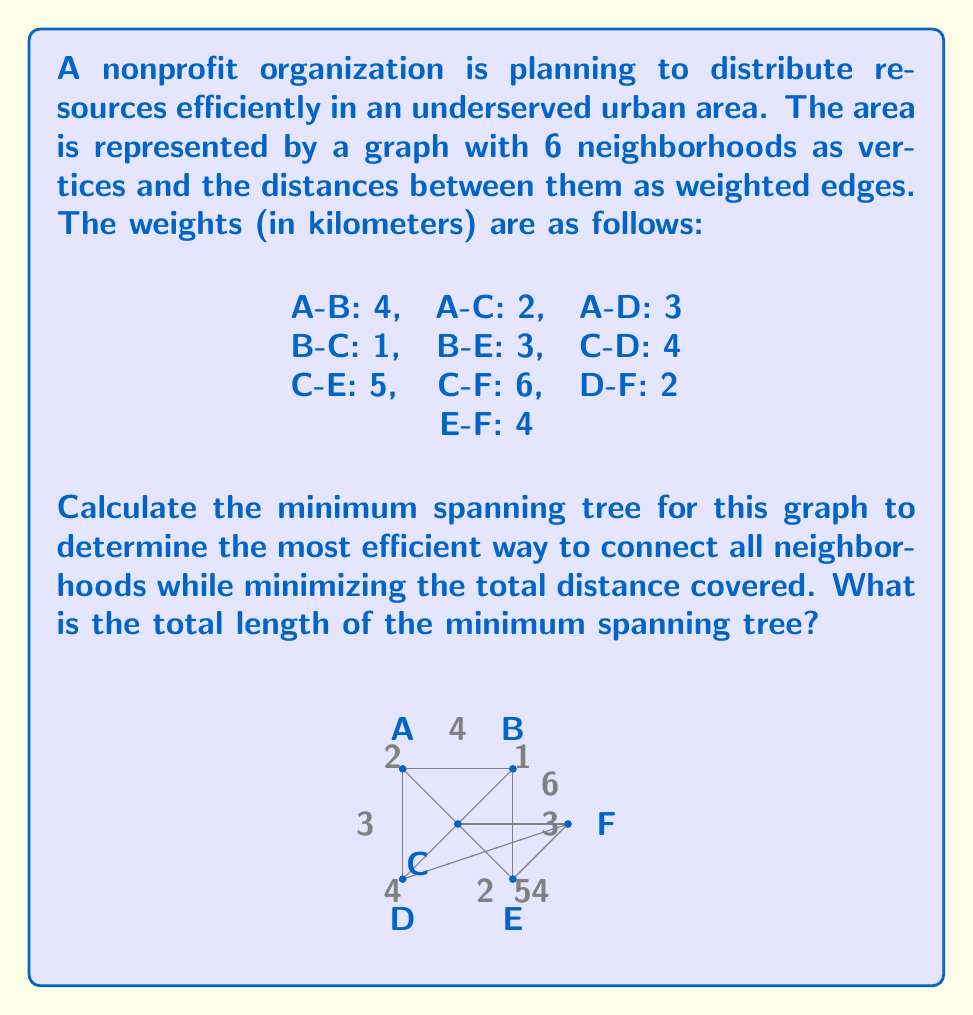Could you help me with this problem? To solve this problem, we'll use Kruskal's algorithm to find the minimum spanning tree (MST). Kruskal's algorithm works by sorting all edges by weight and then adding them to the MST if they don't create a cycle. Here's the step-by-step process:

1) Sort the edges by weight:
   B-C: 1
   A-C: 2
   D-F: 2
   A-D: 3
   B-E: 3
   A-B: 4
   C-D: 4
   E-F: 4
   C-E: 5
   C-F: 6

2) Start adding edges to the MST:
   - Add B-C (1 km)
   - Add A-C (2 km)
   - Add D-F (2 km)
   - Add A-D (3 km)
   - Add B-E (3 km)

3) At this point, we have added 5 edges, which is correct for a MST of a graph with 6 vertices (n-1 edges where n is the number of vertices).

4) Calculate the total length of the MST:
   $$ 1 + 2 + 2 + 3 + 3 = 11 \text{ km} $$

The resulting MST connects all neighborhoods with the minimum total distance.

[asy]
unitsize(30);
pair A = (0,2), B = (2,2), C = (1,1), D = (0,0), E = (2,0), F = (3,1);
draw(A--C,linewidth(1)); draw(A--D,linewidth(1));
draw(B--C,linewidth(1)); draw(B--E,linewidth(1)); draw(D--F,linewidth(1));
dot(A); dot(B); dot(C); dot(D); dot(E); dot(F);
label("A", A, N); label("B", B, N); label("C", C, SW); 
label("D", D, S); label("E", E, S); label("F", F, E);
label("2", (A+C)/2, NW); label("3", (A+D)/2, W);
label("1", (B+C)/2, NE); label("3", (B+E)/2, E);
label("2", (D+F)/2, S);
[/asy]
Answer: The total length of the minimum spanning tree is 11 km. 